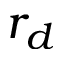Convert formula to latex. <formula><loc_0><loc_0><loc_500><loc_500>r _ { d }</formula> 